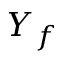Convert formula to latex. <formula><loc_0><loc_0><loc_500><loc_500>Y _ { f }</formula> 